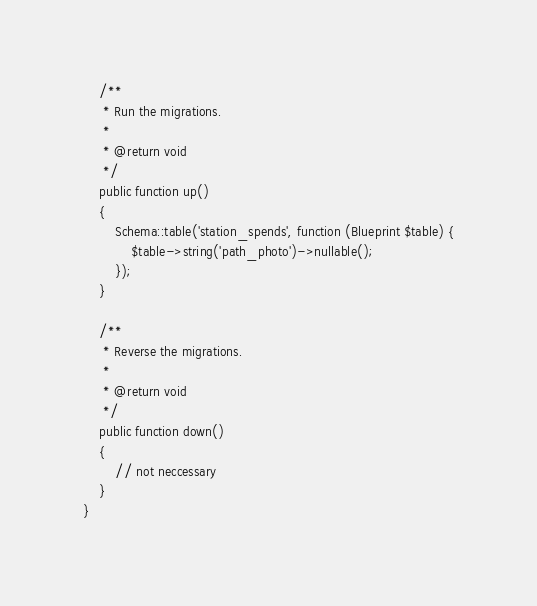<code> <loc_0><loc_0><loc_500><loc_500><_PHP_>    /**
     * Run the migrations.
     *
     * @return void
     */
    public function up()
    {
        Schema::table('station_spends', function (Blueprint $table) {
            $table->string('path_photo')->nullable();
        });
    }

    /**
     * Reverse the migrations.
     *
     * @return void
     */
    public function down()
    {
        // not neccessary
    }
}
</code> 